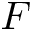<formula> <loc_0><loc_0><loc_500><loc_500>F</formula> 